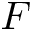<formula> <loc_0><loc_0><loc_500><loc_500>F</formula> 